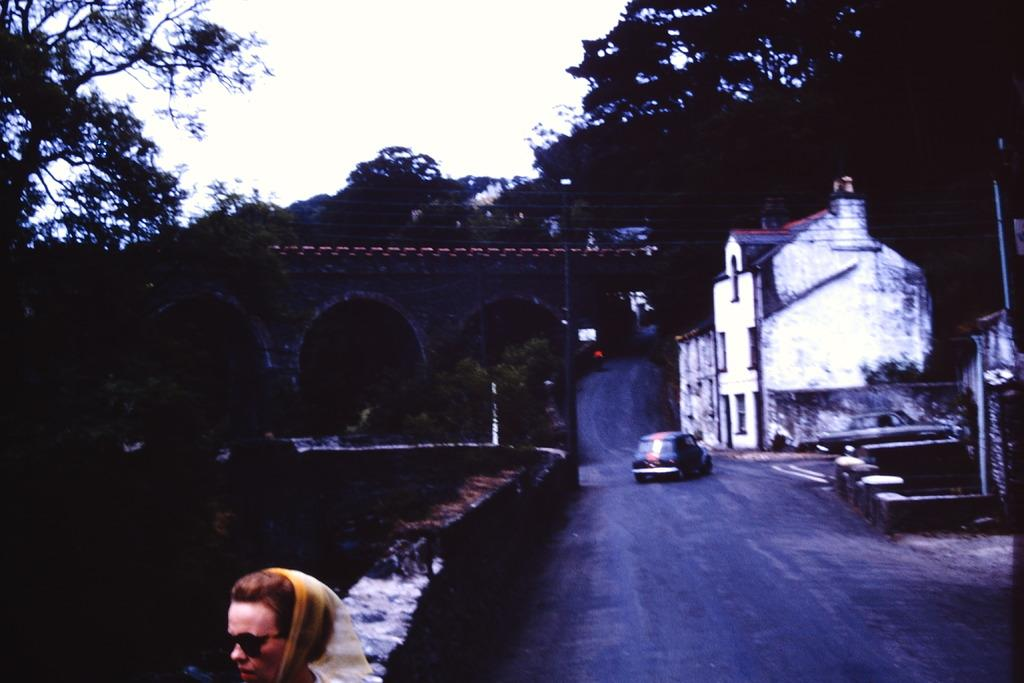What type of natural elements can be seen in the image? There are trees in the image. What type of man-made structures are visible in the image? There are buildings in the image. What mode of transportation can be seen on the road in the image? There is a car on the road in the image. Can you describe the woman in the image? The woman in the image is wearing sunglasses. How would you describe the weather in the image? The sky is cloudy in the image. Is the woman in the image interacting with a stranger in the quicksand? There is no quicksand or stranger present in the image. The woman is wearing sunglasses and standing near a car on the road. 